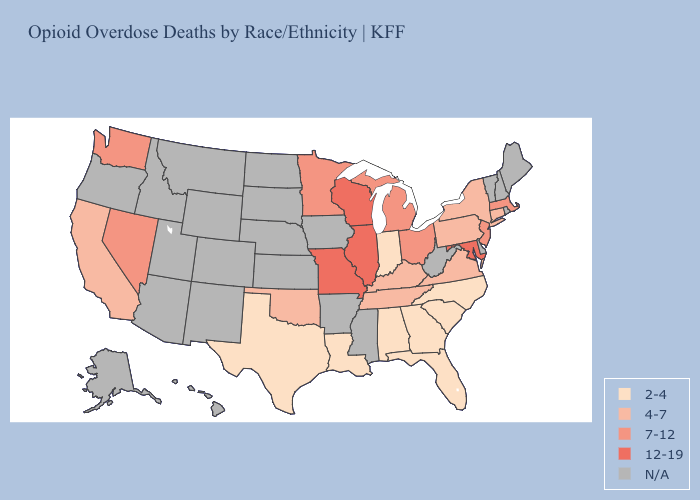What is the lowest value in the USA?
Give a very brief answer. 2-4. What is the value of Colorado?
Be succinct. N/A. Does Nevada have the lowest value in the West?
Short answer required. No. Among the states that border Michigan , does Indiana have the lowest value?
Be succinct. Yes. Among the states that border Ohio , which have the highest value?
Give a very brief answer. Michigan. What is the value of Kentucky?
Quick response, please. 4-7. What is the highest value in the MidWest ?
Concise answer only. 12-19. Name the states that have a value in the range 4-7?
Keep it brief. California, Connecticut, Kentucky, New York, Oklahoma, Pennsylvania, Tennessee, Virginia. Which states have the highest value in the USA?
Write a very short answer. Illinois, Maryland, Missouri, Wisconsin. Does Indiana have the lowest value in the USA?
Short answer required. Yes. Name the states that have a value in the range 4-7?
Concise answer only. California, Connecticut, Kentucky, New York, Oklahoma, Pennsylvania, Tennessee, Virginia. What is the value of Connecticut?
Be succinct. 4-7. What is the lowest value in the USA?
Short answer required. 2-4. 